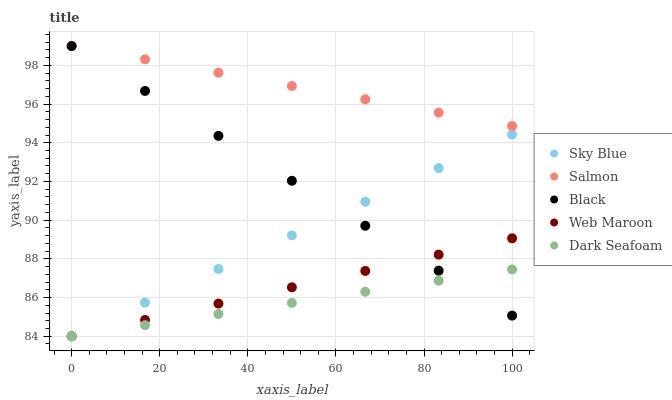Does Dark Seafoam have the minimum area under the curve?
Answer yes or no. Yes. Does Salmon have the maximum area under the curve?
Answer yes or no. Yes. Does Sky Blue have the minimum area under the curve?
Answer yes or no. No. Does Sky Blue have the maximum area under the curve?
Answer yes or no. No. Is Sky Blue the smoothest?
Answer yes or no. Yes. Is Web Maroon the roughest?
Answer yes or no. Yes. Is Dark Seafoam the smoothest?
Answer yes or no. No. Is Dark Seafoam the roughest?
Answer yes or no. No. Does Web Maroon have the lowest value?
Answer yes or no. Yes. Does Salmon have the lowest value?
Answer yes or no. No. Does Black have the highest value?
Answer yes or no. Yes. Does Sky Blue have the highest value?
Answer yes or no. No. Is Web Maroon less than Salmon?
Answer yes or no. Yes. Is Salmon greater than Dark Seafoam?
Answer yes or no. Yes. Does Sky Blue intersect Web Maroon?
Answer yes or no. Yes. Is Sky Blue less than Web Maroon?
Answer yes or no. No. Is Sky Blue greater than Web Maroon?
Answer yes or no. No. Does Web Maroon intersect Salmon?
Answer yes or no. No. 